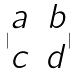Convert formula to latex. <formula><loc_0><loc_0><loc_500><loc_500>| \begin{matrix} a & b \\ c & d \end{matrix} |</formula> 